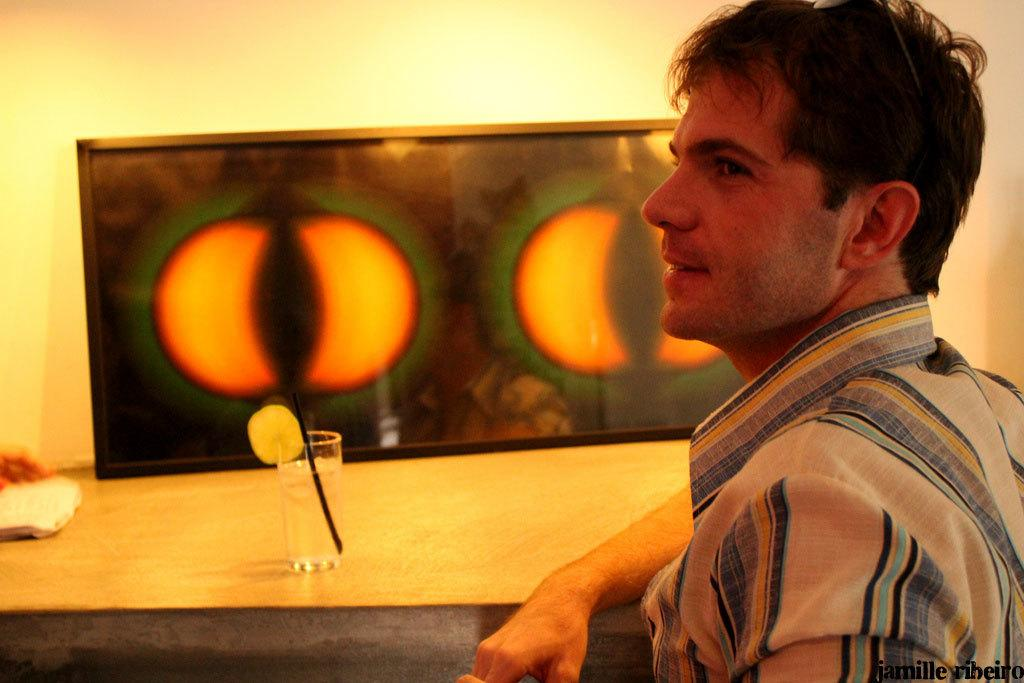Who is present in the image? There is a person in the image. What is the person doing in the image? The person is in front of a table. What can be seen on the table in the image? There is a glass with a straw on the table. What is on the wall in the image? There is a frame on the wall. What type of crime is being committed in the image? There is no crime being committed in the image; it simply shows a person standing in front of a table with a glass and a straw on it. What kind of shoe is the person wearing in the image? The image does not show the person's shoes, so it cannot be determined what type of shoe they are wearing. 